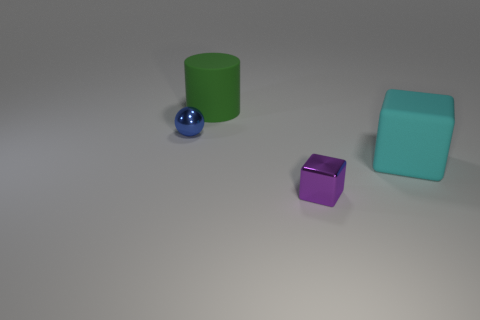There is a purple shiny thing; is its shape the same as the cyan object that is in front of the large cylinder?
Provide a succinct answer. Yes. How many big cyan matte things have the same shape as the tiny purple metallic object?
Your answer should be compact. 1. There is a object that is both on the left side of the big matte cube and in front of the tiny ball; what is it made of?
Provide a succinct answer. Metal. Are the large cyan cube and the large green cylinder made of the same material?
Offer a very short reply. Yes. How many shiny objects are there?
Make the answer very short. 2. What color is the large matte thing that is right of the large object that is on the left side of the cyan thing on the right side of the tiny purple object?
Your answer should be compact. Cyan. How many things are to the left of the large cyan cube and behind the tiny purple shiny cube?
Keep it short and to the point. 2. How many rubber things are either cylinders or tiny yellow spheres?
Make the answer very short. 1. There is a tiny object behind the small metal thing that is right of the big rubber cylinder; what is it made of?
Offer a terse response. Metal. The cyan thing that is the same size as the green object is what shape?
Make the answer very short. Cube. 